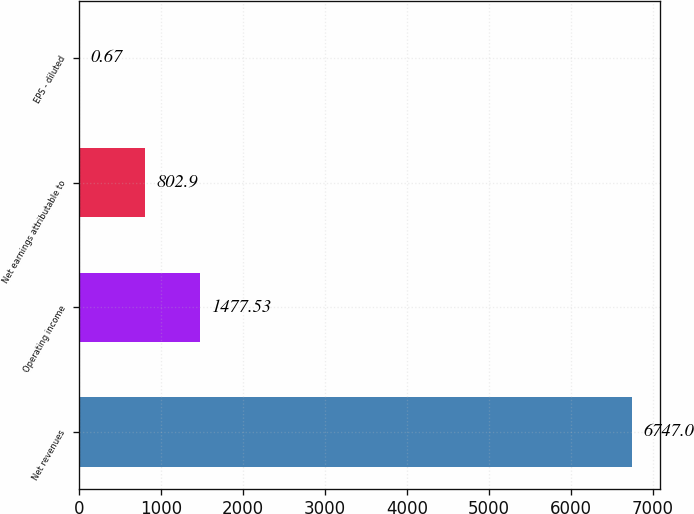<chart> <loc_0><loc_0><loc_500><loc_500><bar_chart><fcel>Net revenues<fcel>Operating income<fcel>Net earnings attributable to<fcel>EPS - diluted<nl><fcel>6747<fcel>1477.53<fcel>802.9<fcel>0.67<nl></chart> 